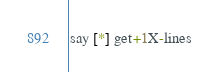Convert code to text. <code><loc_0><loc_0><loc_500><loc_500><_Perl_>say [*] get+1X-lines</code> 